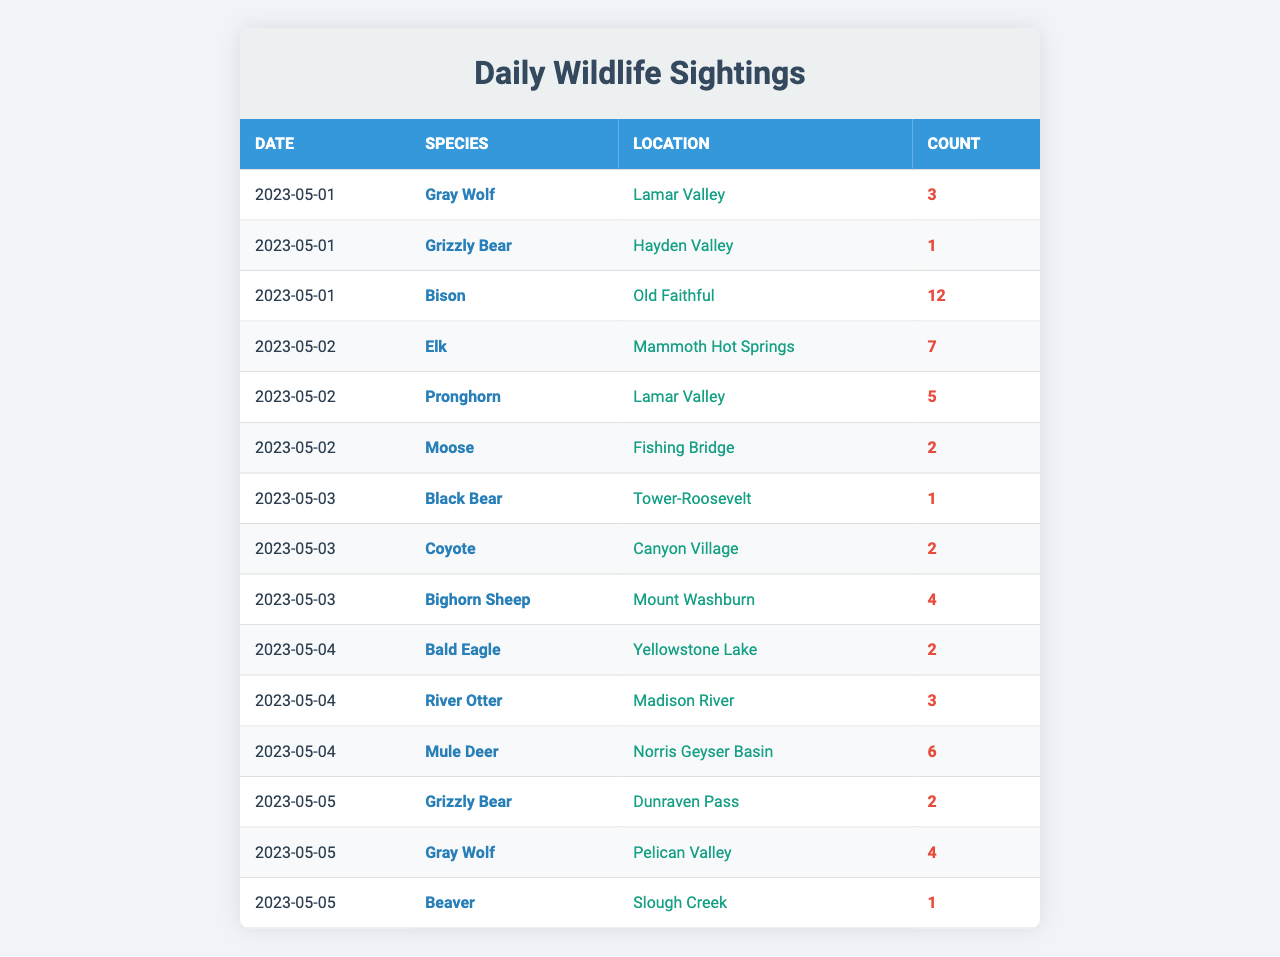What species was sighted in Lamar Valley on May 1, 2023? Referring to the table, on May 1, 2023, the species sighted in Lamar Valley is the Gray Wolf with a count of 3.
Answer: Gray Wolf How many Grizzly Bears were observed on May 5, 2023? The table shows that on May 5, 2023, there were 2 Grizzly Bears sighted.
Answer: 2 Which location had the highest count of wildlife sightings on May 1, 2023? On May 1, 2023, Old Faithful had the highest count of 12 Bison sightings, more than any other species or location on that date.
Answer: Old Faithful What is the total number of Moose sightings recorded? By checking all records, there were 2 Moose sightings on May 2, which can be summed up as 2.
Answer: 2 Is there any day when more than 10 wildlife sightings were recorded? On May 1, 2023, there was a total of 16 wildlife sightings (3 Gray Wolves + 1 Grizzly Bear + 12 Bison), which exceeds 10 sightings.
Answer: Yes What is the average number of Bison sightings across all days? There was only one count of Bison on May 1 with a total of 12 sightings. The average is thus 12/1 = 12.
Answer: 12 How many unique species were recorded in the table? The table lists the following unique species: Gray Wolf, Grizzly Bear, Bison, Elk, Pronghorn, Moose, Black Bear, Coyote, Bighorn Sheep, Bald Eagle, River Otter, Mule Deer, and Beaver, totaling 12 unique species.
Answer: 12 What is the total count of wildlife sightings on May 2, 2023? Summing the sightings on May 2, 2023: 7 Elk + 5 Pronghorn + 2 Moose = 14.
Answer: 14 On which date was the highest number of wildlife sightings recorded, and what was that number? The highest number of wildlife sightings occurred on May 1, 2023, with a total of 16 sightings (3 Gray Wolves + 1 Grizzly Bear + 12 Bison).
Answer: May 1, 16 How many wildlife sightings were recorded in the Fishing Bridge location over all days? The only entry for Fishing Bridge shows 2 Moose sightings. There are no other records for this location.
Answer: 2 